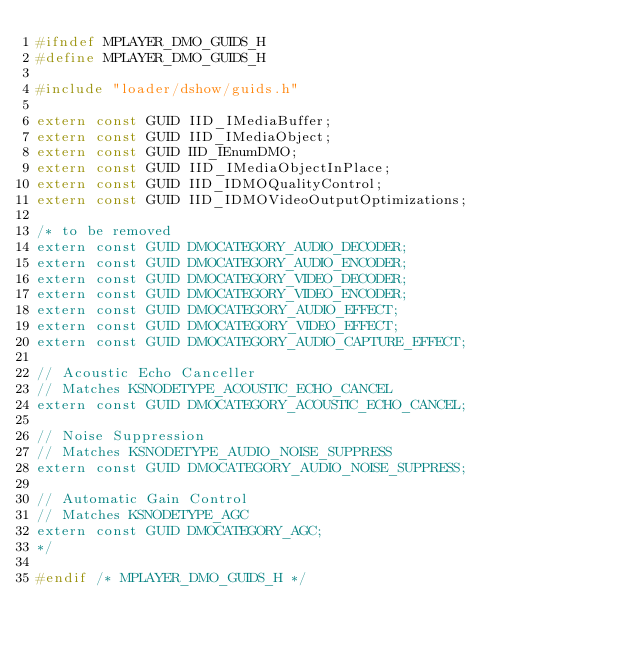<code> <loc_0><loc_0><loc_500><loc_500><_C_>#ifndef MPLAYER_DMO_GUIDS_H
#define MPLAYER_DMO_GUIDS_H

#include "loader/dshow/guids.h"

extern const GUID IID_IMediaBuffer;
extern const GUID IID_IMediaObject;
extern const GUID IID_IEnumDMO;
extern const GUID IID_IMediaObjectInPlace;
extern const GUID IID_IDMOQualityControl;
extern const GUID IID_IDMOVideoOutputOptimizations;

/* to be removed
extern const GUID DMOCATEGORY_AUDIO_DECODER;
extern const GUID DMOCATEGORY_AUDIO_ENCODER;
extern const GUID DMOCATEGORY_VIDEO_DECODER;
extern const GUID DMOCATEGORY_VIDEO_ENCODER;
extern const GUID DMOCATEGORY_AUDIO_EFFECT;
extern const GUID DMOCATEGORY_VIDEO_EFFECT;
extern const GUID DMOCATEGORY_AUDIO_CAPTURE_EFFECT;

// Acoustic Echo Canceller
// Matches KSNODETYPE_ACOUSTIC_ECHO_CANCEL
extern const GUID DMOCATEGORY_ACOUSTIC_ECHO_CANCEL;

// Noise Suppression
// Matches KSNODETYPE_AUDIO_NOISE_SUPPRESS
extern const GUID DMOCATEGORY_AUDIO_NOISE_SUPPRESS;

// Automatic Gain Control
// Matches KSNODETYPE_AGC
extern const GUID DMOCATEGORY_AGC;
*/

#endif /* MPLAYER_DMO_GUIDS_H */
</code> 